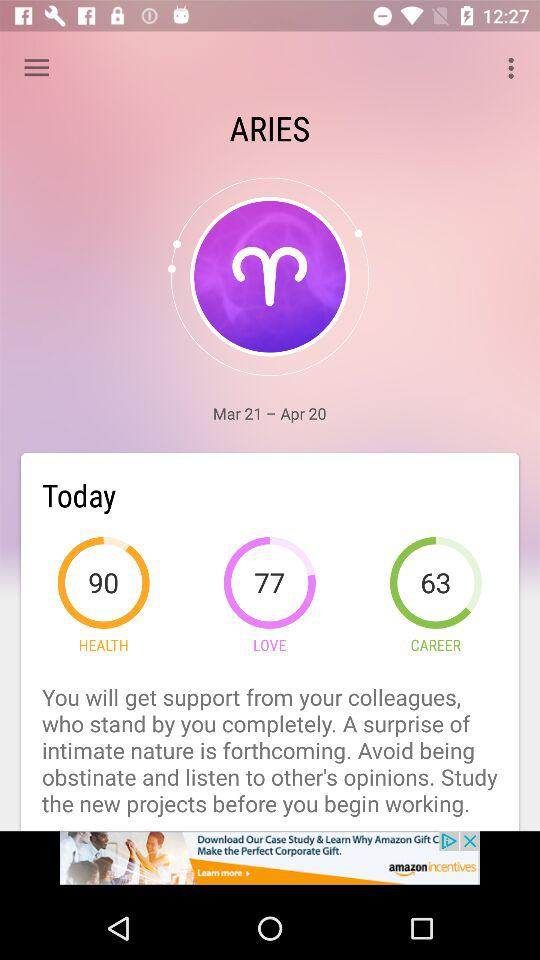What zodiac sign is there? The zodiac sign is "ARIES". 